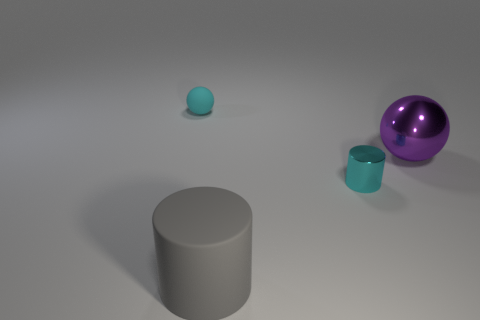Add 2 large cylinders. How many objects exist? 6 Subtract all large blocks. Subtract all metallic objects. How many objects are left? 2 Add 2 purple spheres. How many purple spheres are left? 3 Add 1 rubber cylinders. How many rubber cylinders exist? 2 Subtract 0 yellow cylinders. How many objects are left? 4 